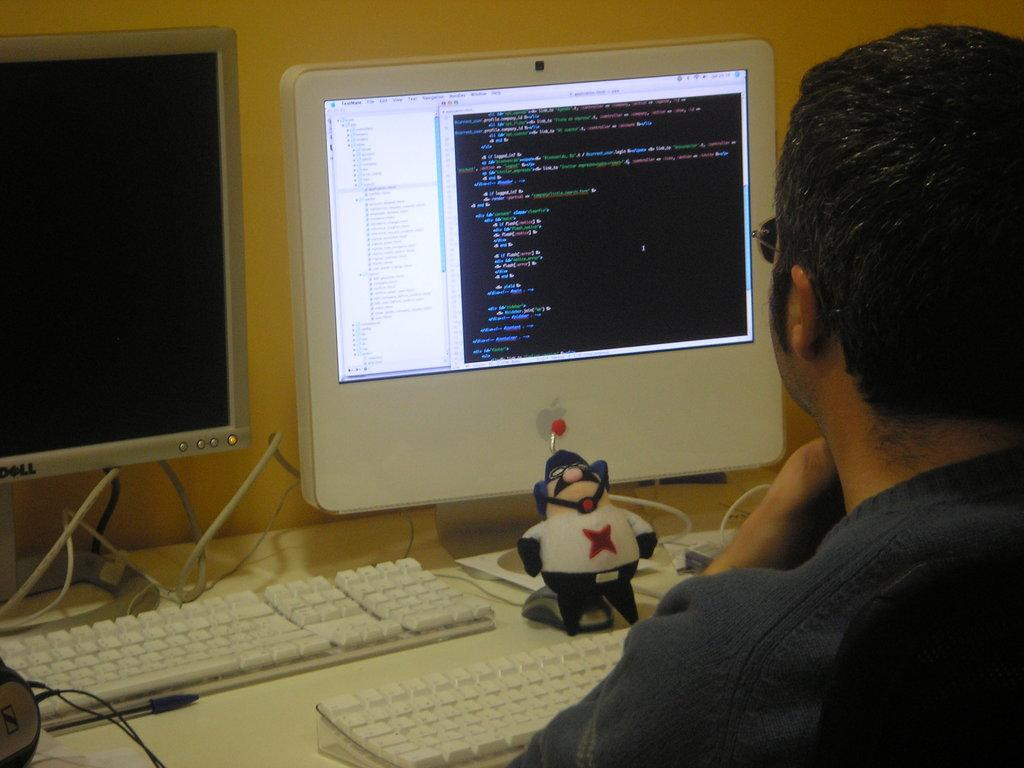What color is the wall that can be seen in the image? The wall in the image is yellow. How many screens are visible in the image? There are two screens in the image. What objects are used for typing in the image? Keyboards are visible in the image. What piece of furniture is present in the image? There is a table in the image. Where is the man located in the image? The man is on the right side of the image. What type of flowers are on the table in the image? There are no flowers present in the image; it features a table with screens and keyboards. How many kittens are visible on the right side of the image? There are no kittens present in the image; it features a man on the right side. 